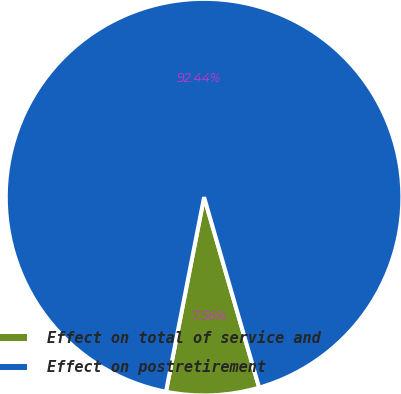<chart> <loc_0><loc_0><loc_500><loc_500><pie_chart><fcel>Effect on total of service and<fcel>Effect on postretirement<nl><fcel>7.56%<fcel>92.44%<nl></chart> 